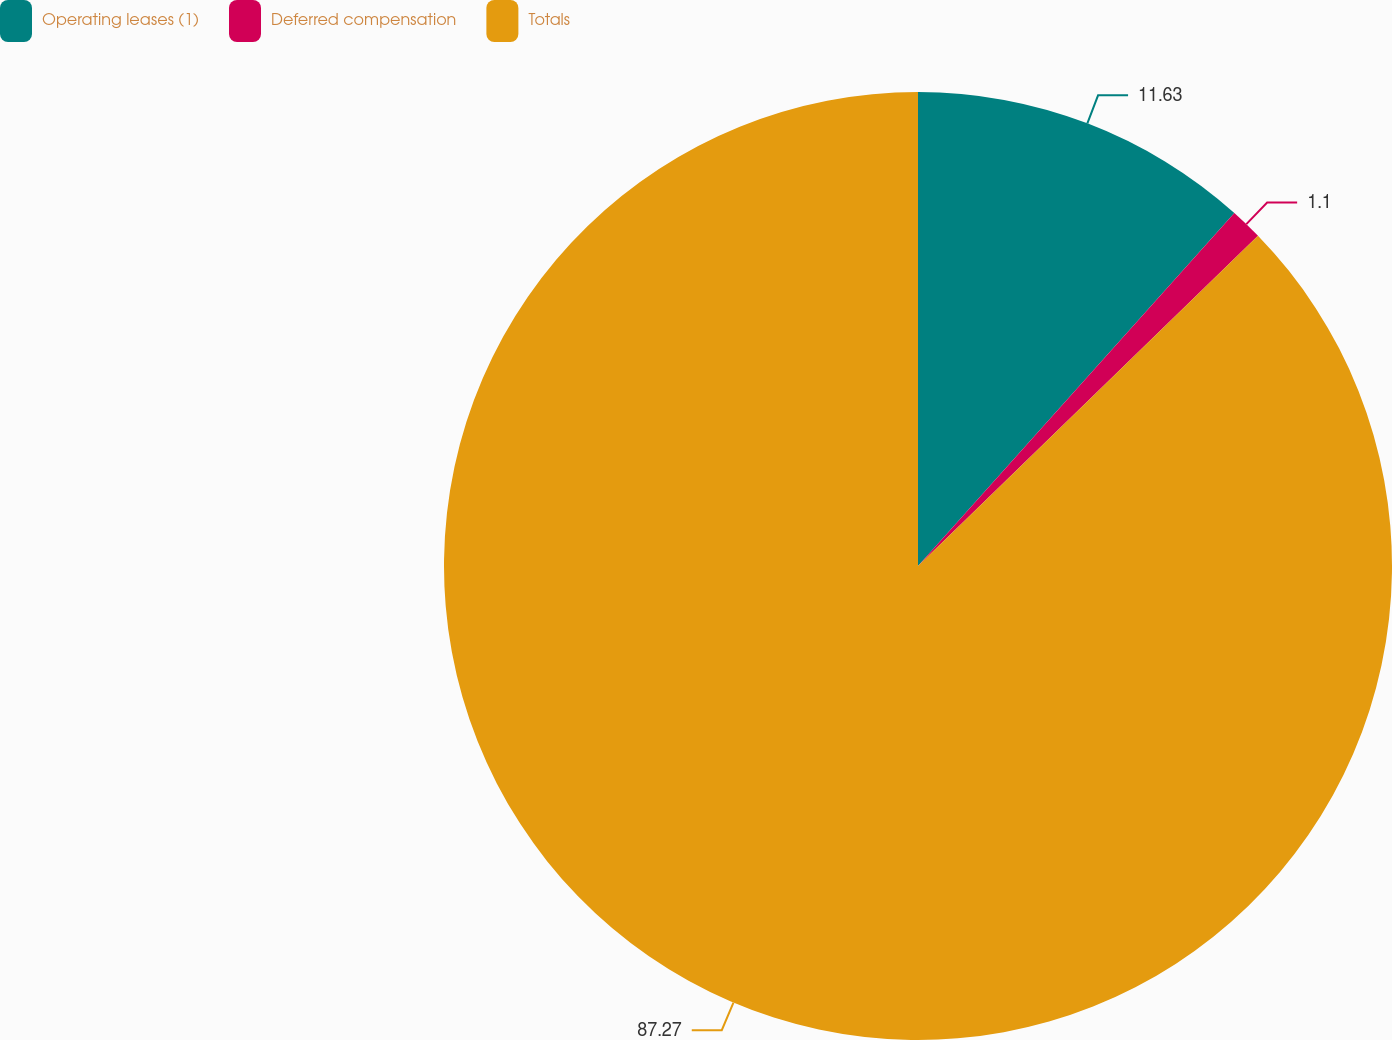Convert chart. <chart><loc_0><loc_0><loc_500><loc_500><pie_chart><fcel>Operating leases (1)<fcel>Deferred compensation<fcel>Totals<nl><fcel>11.63%<fcel>1.1%<fcel>87.27%<nl></chart> 